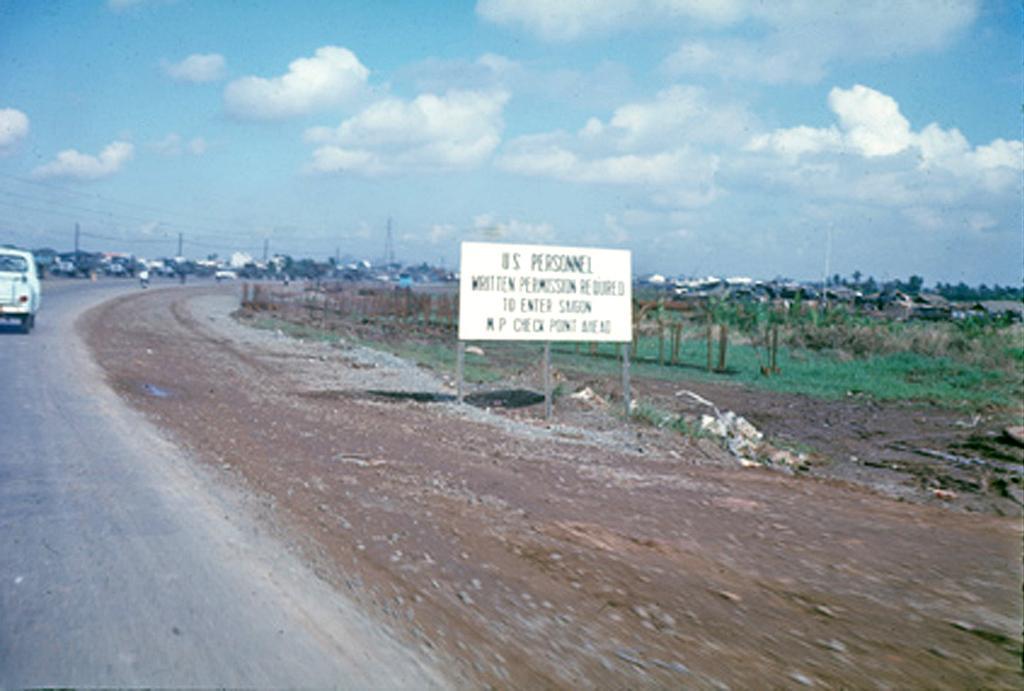How would you summarize this image in a sentence or two? In the image we can see a vehicle on the road. This is a road, sand, grass, board, pole, electric wires, trees and a cloudy sky. 